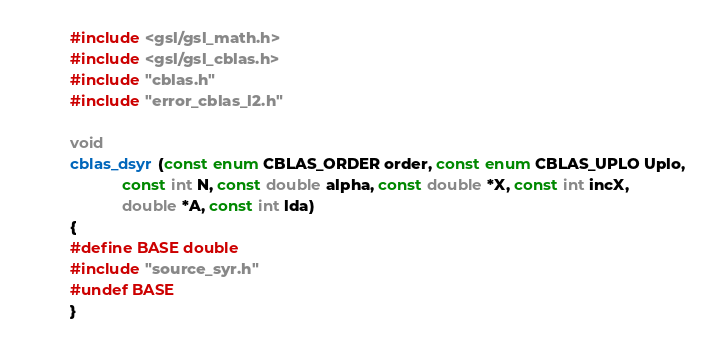<code> <loc_0><loc_0><loc_500><loc_500><_C_>#include <gsl/gsl_math.h>
#include <gsl/gsl_cblas.h>
#include "cblas.h"
#include "error_cblas_l2.h"

void
cblas_dsyr (const enum CBLAS_ORDER order, const enum CBLAS_UPLO Uplo,
            const int N, const double alpha, const double *X, const int incX,
            double *A, const int lda)
{
#define BASE double
#include "source_syr.h"
#undef BASE
}
</code> 